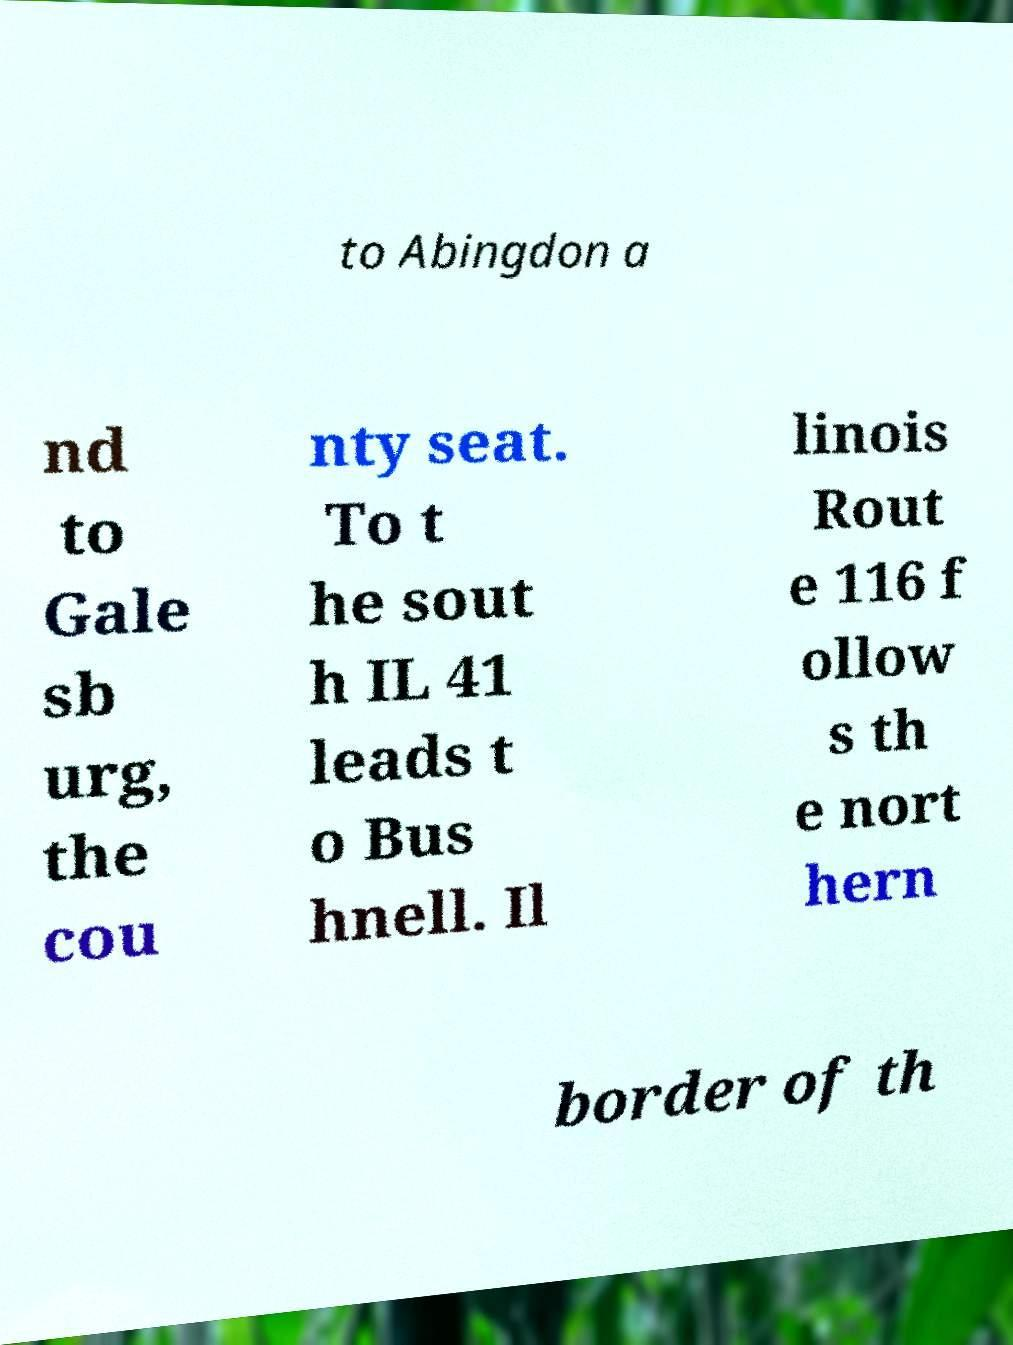Please read and relay the text visible in this image. What does it say? to Abingdon a nd to Gale sb urg, the cou nty seat. To t he sout h IL 41 leads t o Bus hnell. Il linois Rout e 116 f ollow s th e nort hern border of th 